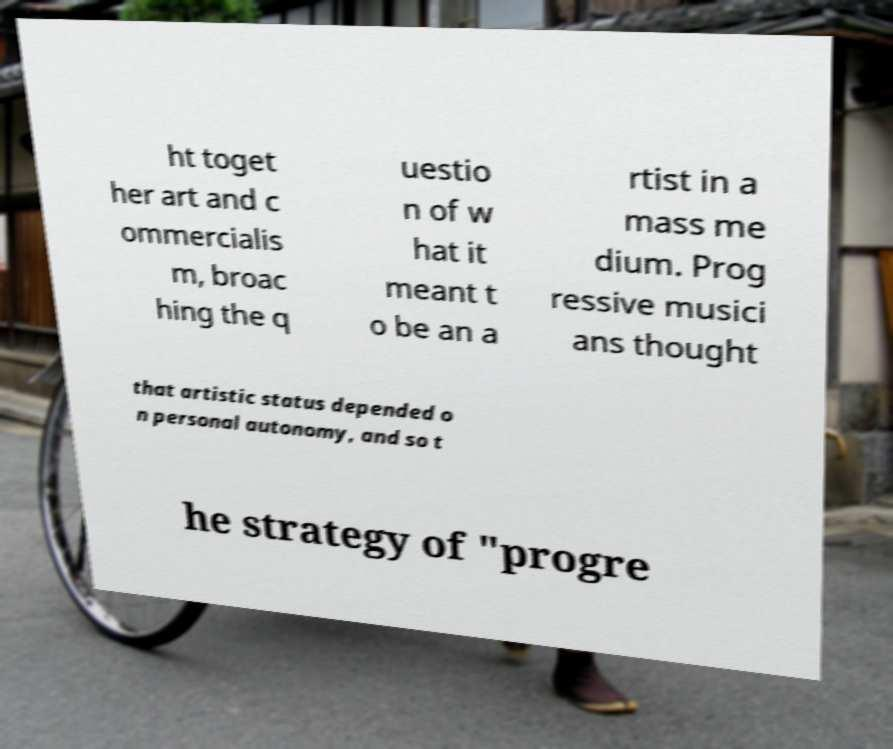Could you extract and type out the text from this image? ht toget her art and c ommercialis m, broac hing the q uestio n of w hat it meant t o be an a rtist in a mass me dium. Prog ressive musici ans thought that artistic status depended o n personal autonomy, and so t he strategy of "progre 